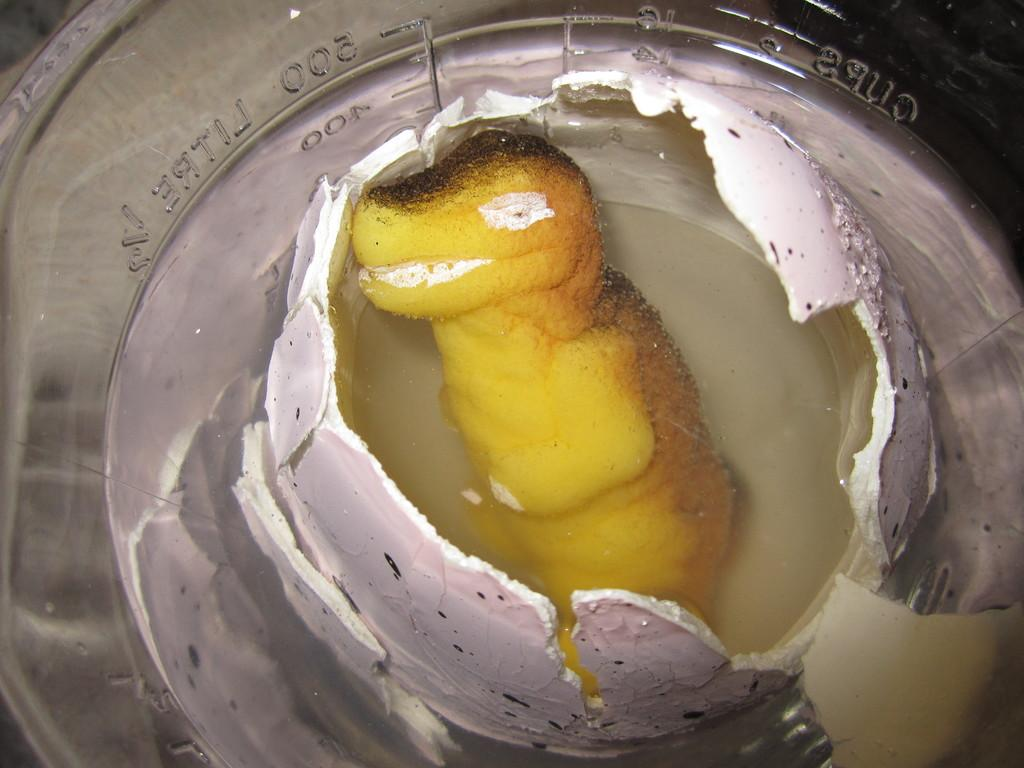What is in the bowl that is visible in the image? There is a bowl in the image, and it contains a broken egg. What is the consistency of the contents in the bowl? There is liquid in the bowl, which suggests that the broken egg has released its contents. What is the value of the minister's aftermath in the image? There is no minister or aftermath present in the image; it only features a bowl with a broken egg and liquid. 